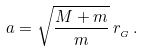<formula> <loc_0><loc_0><loc_500><loc_500>a = \sqrt { \frac { M + m } { m } } \, r _ { _ { G } } \, .</formula> 